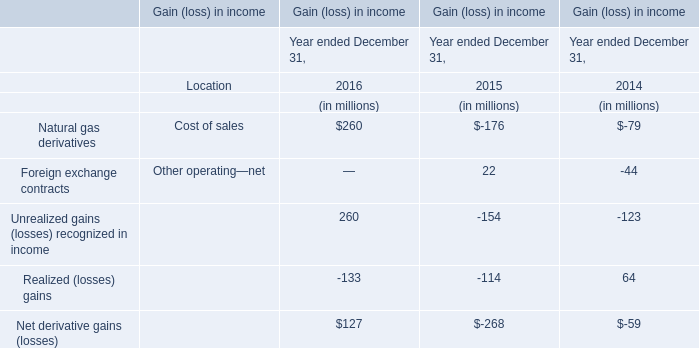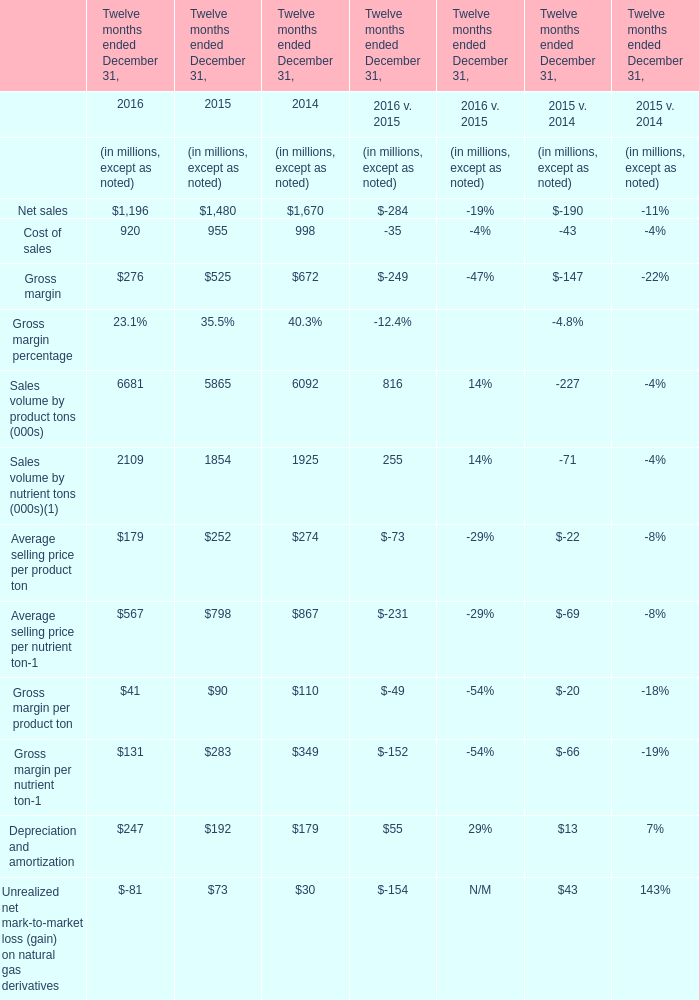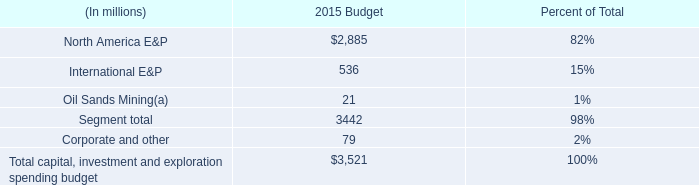What's the 50 % of total Cost of sales in 2016? (in millions) 
Computations: (920 * 0.5)
Answer: 460.0. 